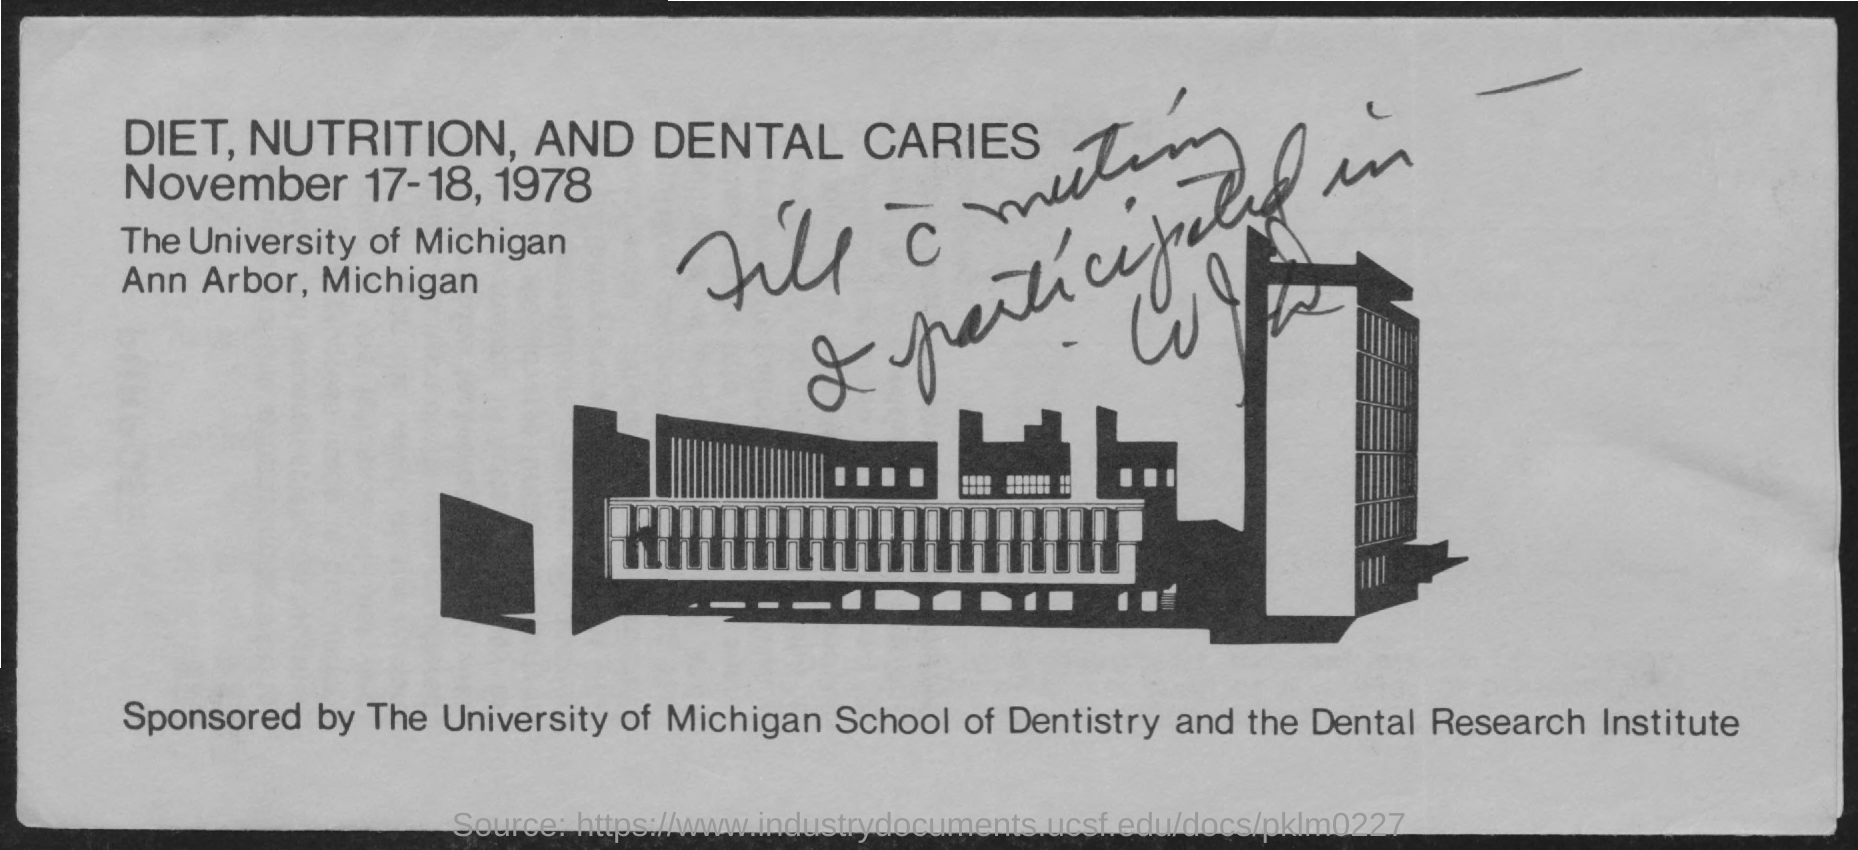What is the date mentioned ?
Provide a short and direct response. November 17-18, 1978. What is  the name of the university ?
Your answer should be very brief. The university of Michigan. Where is the university of michigan located ?
Your response must be concise. Ann Arbor, Michigan. 